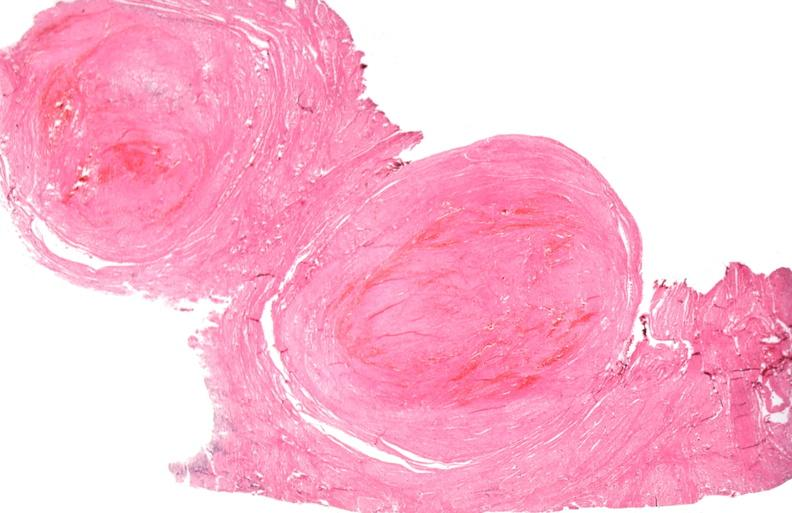where is this from?
Answer the question using a single word or phrase. Female reproductive system 